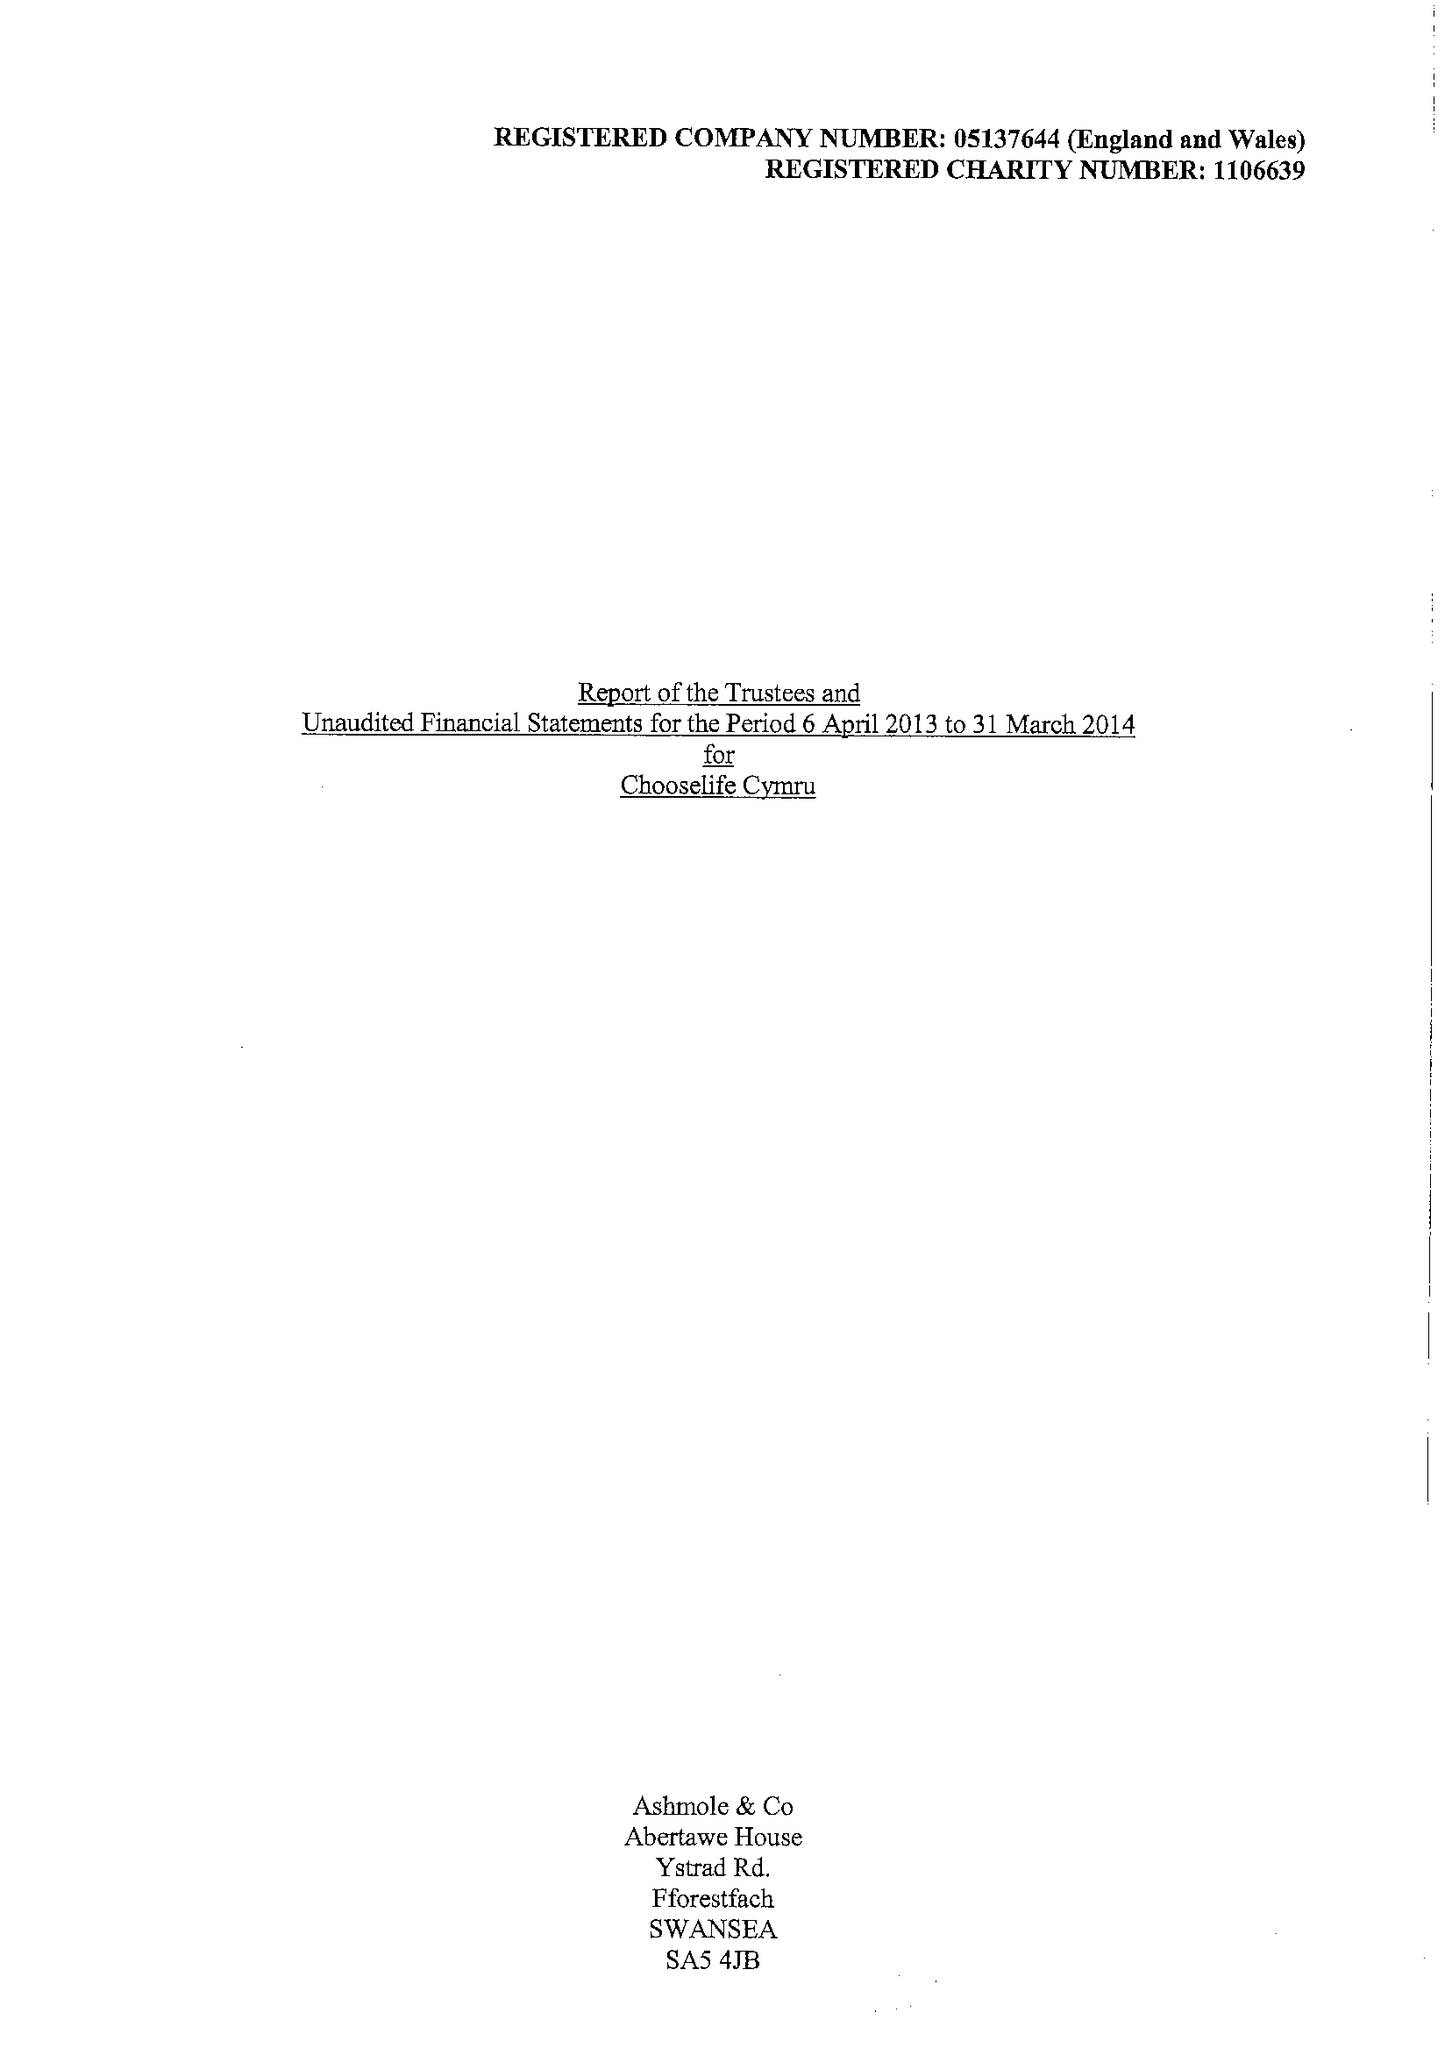What is the value for the address__postcode?
Answer the question using a single word or phrase. SA15 2NE 